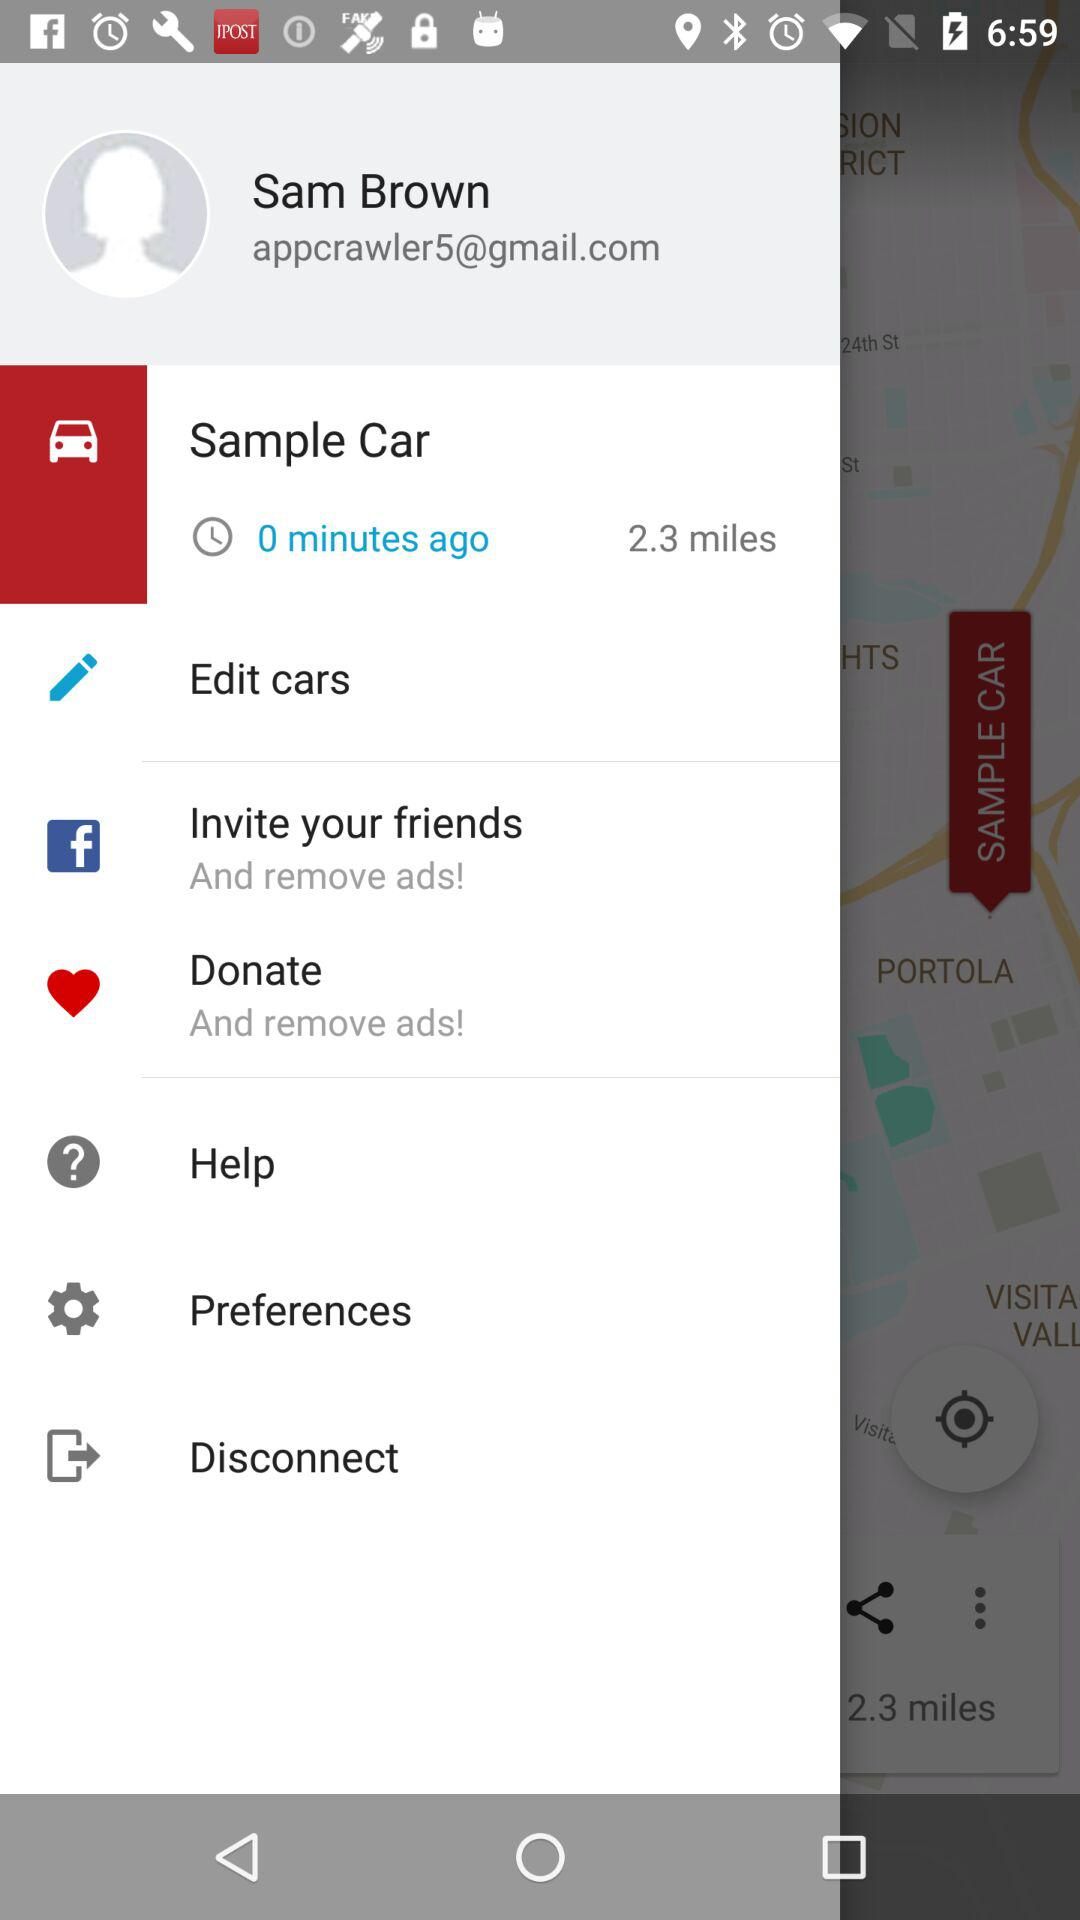What is the email address? The email address is "appcrawler5@gmail.com". 